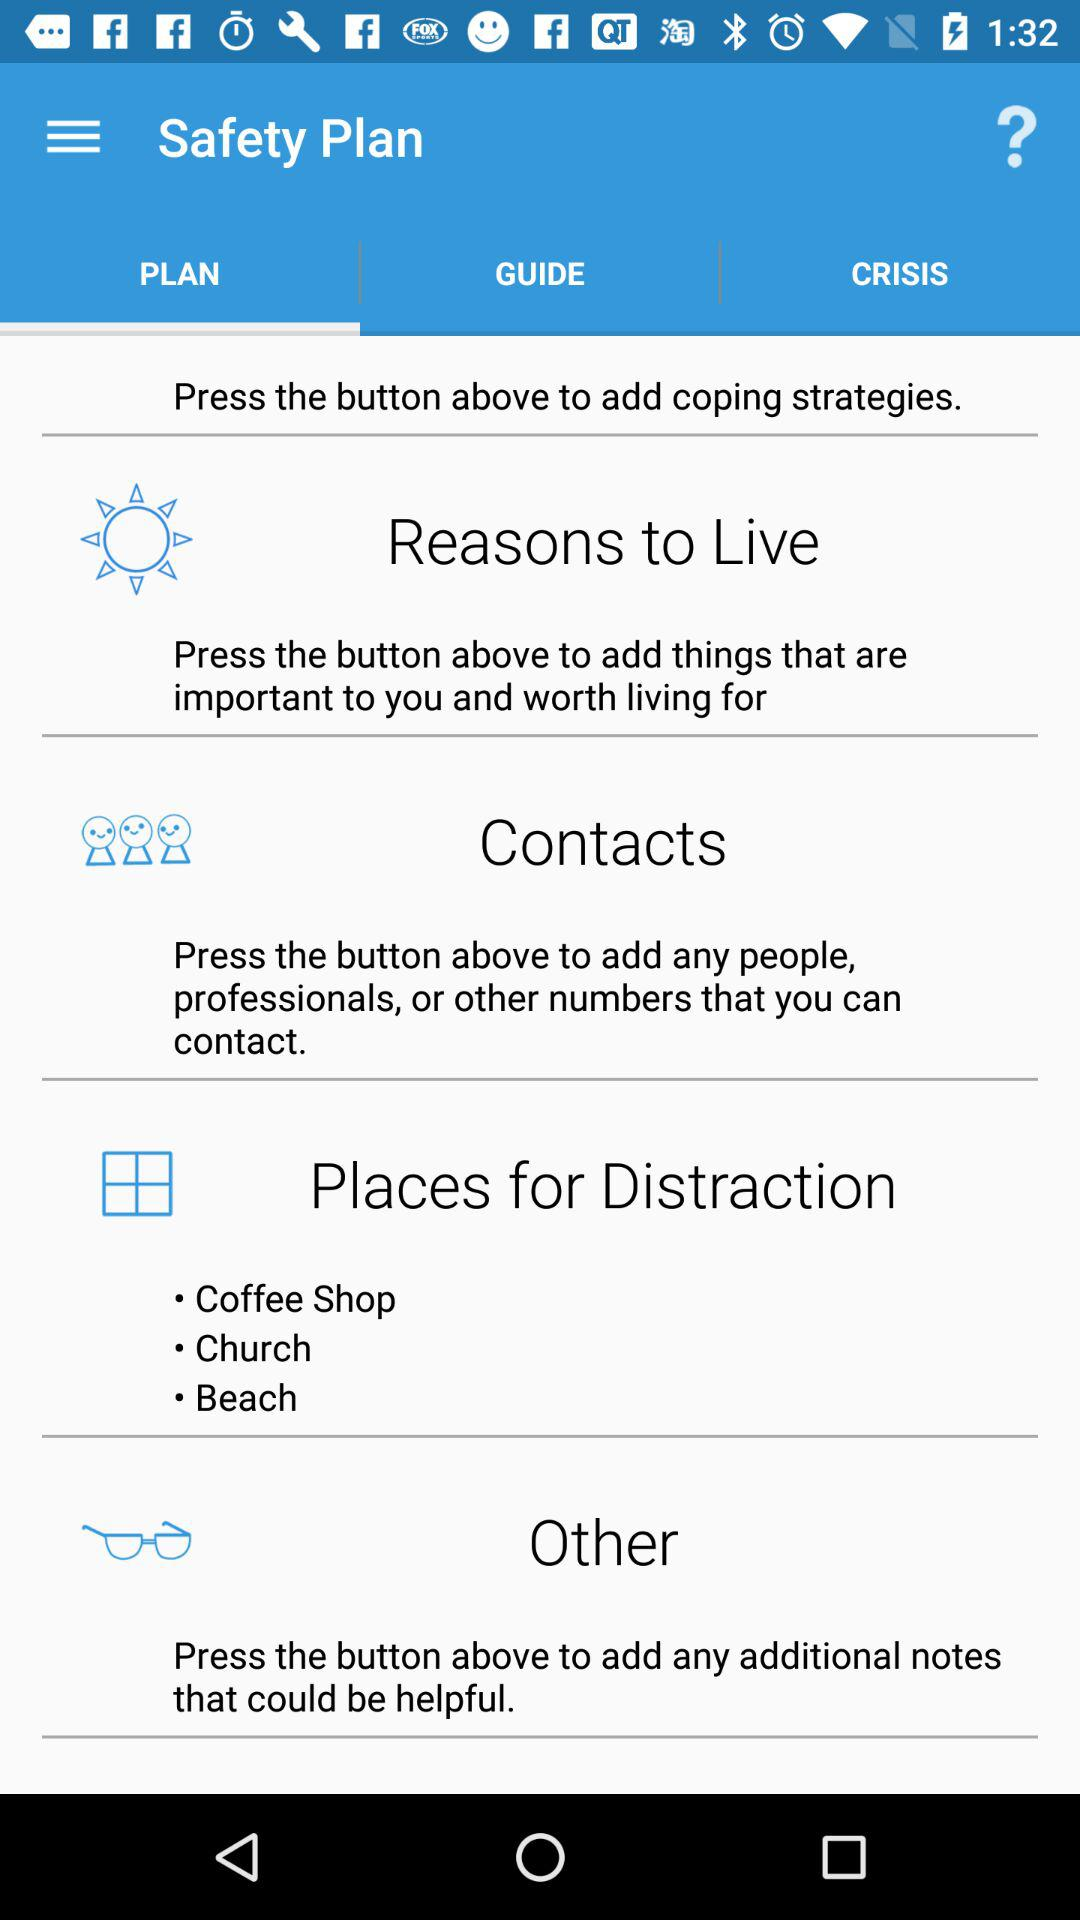Which option is selected? The selected option is "PLAN". 